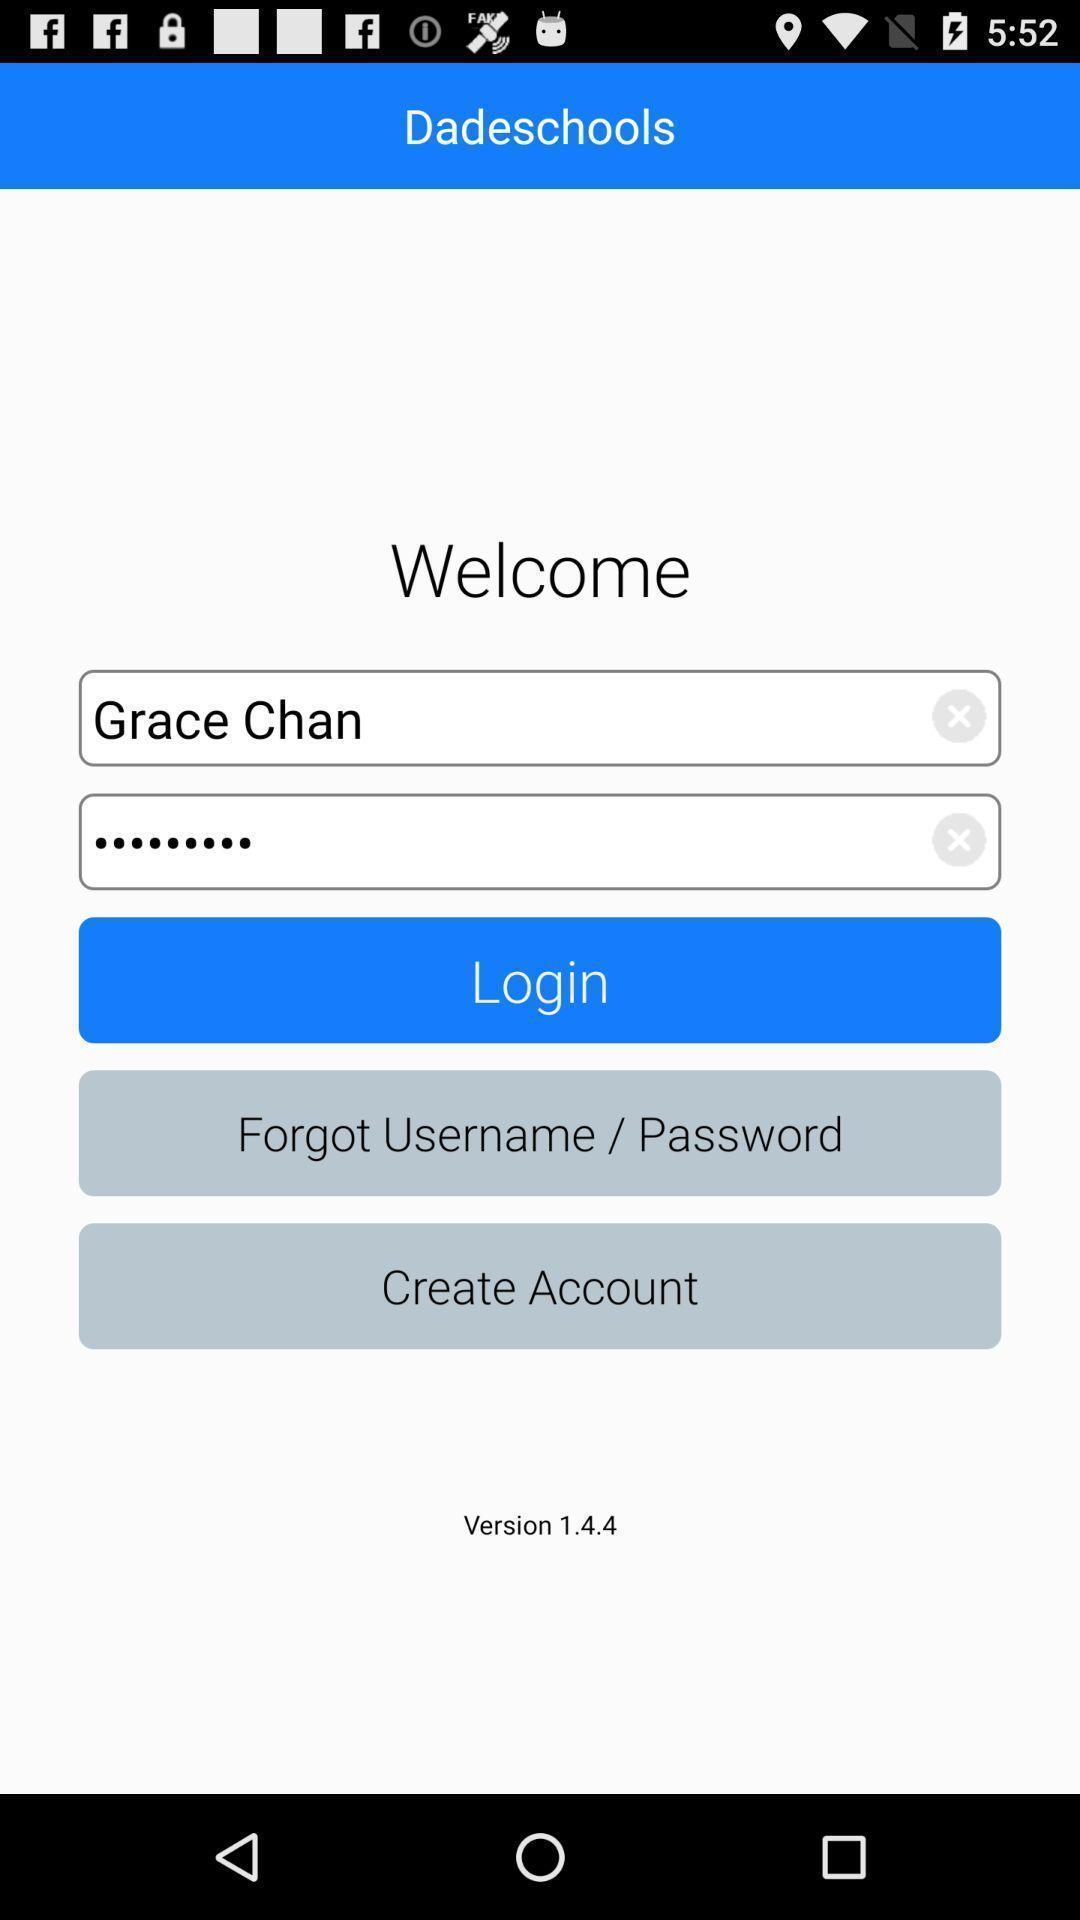Explain the elements present in this screenshot. Welcome page of education application. 